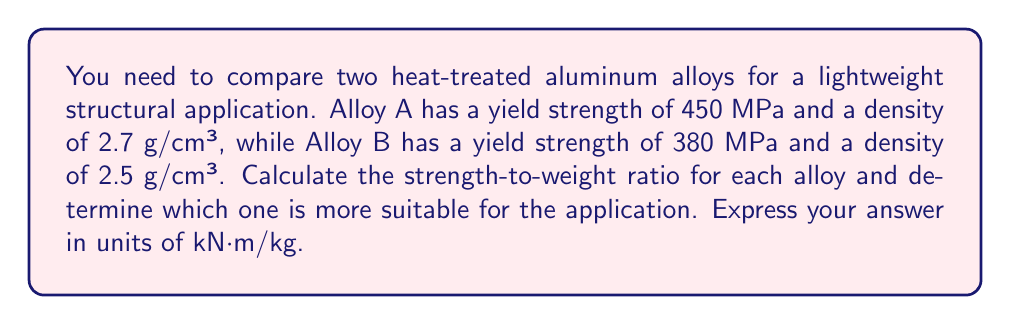Provide a solution to this math problem. To solve this problem, we need to calculate the strength-to-weight ratio for each alloy and compare them. The strength-to-weight ratio is calculated by dividing the yield strength by the specific weight (density multiplied by gravitational acceleration).

Step 1: Convert units
First, let's convert the densities to kg/m³:
Alloy A: $2.7 \text{ g/cm³} = 2700 \text{ kg/m³}$
Alloy B: $2.5 \text{ g/cm³} = 2500 \text{ kg/m³}$

Step 2: Calculate the specific weight
The specific weight is the product of density and gravitational acceleration (g ≈ 9.81 m/s²):

Alloy A: $\gamma_A = 2700 \text{ kg/m³} \times 9.81 \text{ m/s²} = 26,487 \text{ N/m³}$
Alloy B: $\gamma_B = 2500 \text{ kg/m³} \times 9.81 \text{ m/s²} = 24,525 \text{ N/m³}$

Step 3: Calculate the strength-to-weight ratio
For Alloy A:
$$\text{Ratio}_A = \frac{450 \times 10^6 \text{ Pa}}{26,487 \text{ N/m³}} = 16,989 \text{ m} = 16.989 \text{ kN·m/kg}$$

For Alloy B:
$$\text{Ratio}_B = \frac{380 \times 10^6 \text{ Pa}}{24,525 \text{ N/m³}} = 15,494 \text{ m} = 15.494 \text{ kN·m/kg}$$

Step 4: Compare the ratios
Alloy A has a higher strength-to-weight ratio (16.989 kN·m/kg) compared to Alloy B (15.494 kN·m/kg).
Answer: Alloy A: 16.989 kN·m/kg; Alloy B: 15.494 kN·m/kg; Alloy A is more suitable. 